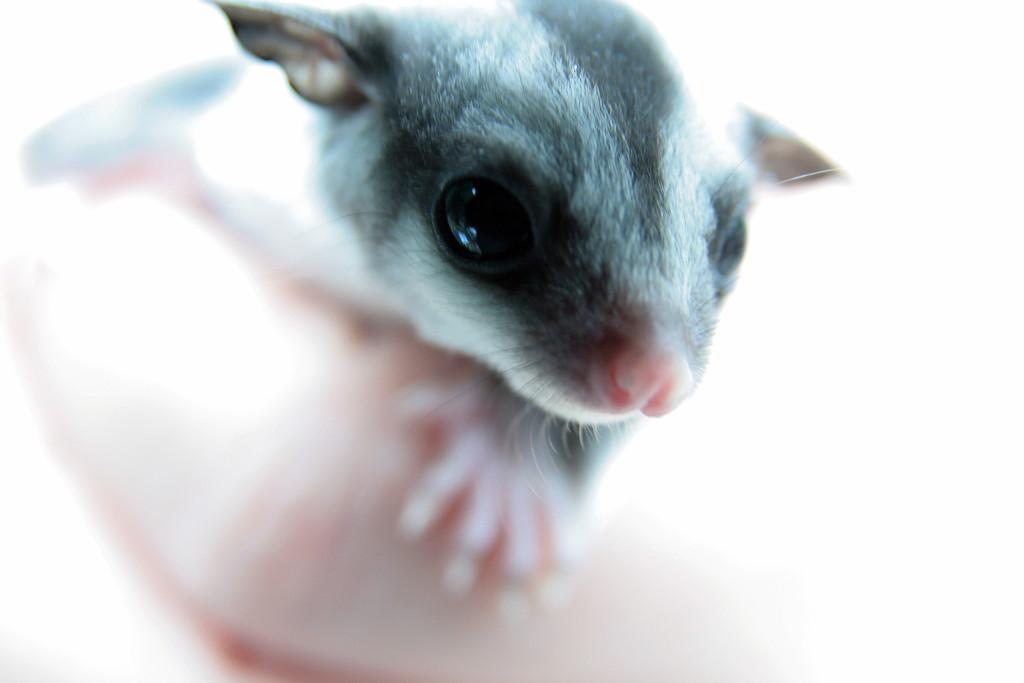What is the main subject of the image? There is an animal in the center of the image. What type of pie is being served on the truck in the image? There is no truck or pie present in the image; it only features an animal in the center. 